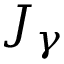Convert formula to latex. <formula><loc_0><loc_0><loc_500><loc_500>J _ { \gamma }</formula> 